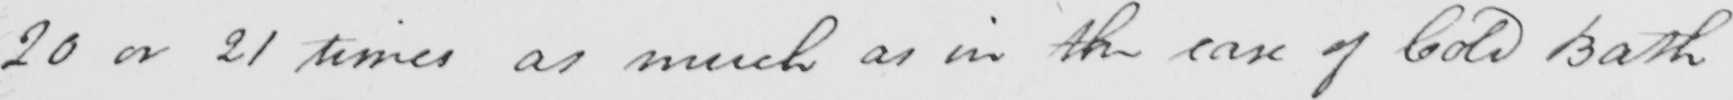What does this handwritten line say? 20 or 21 times as much as in the case of Cold Bath 